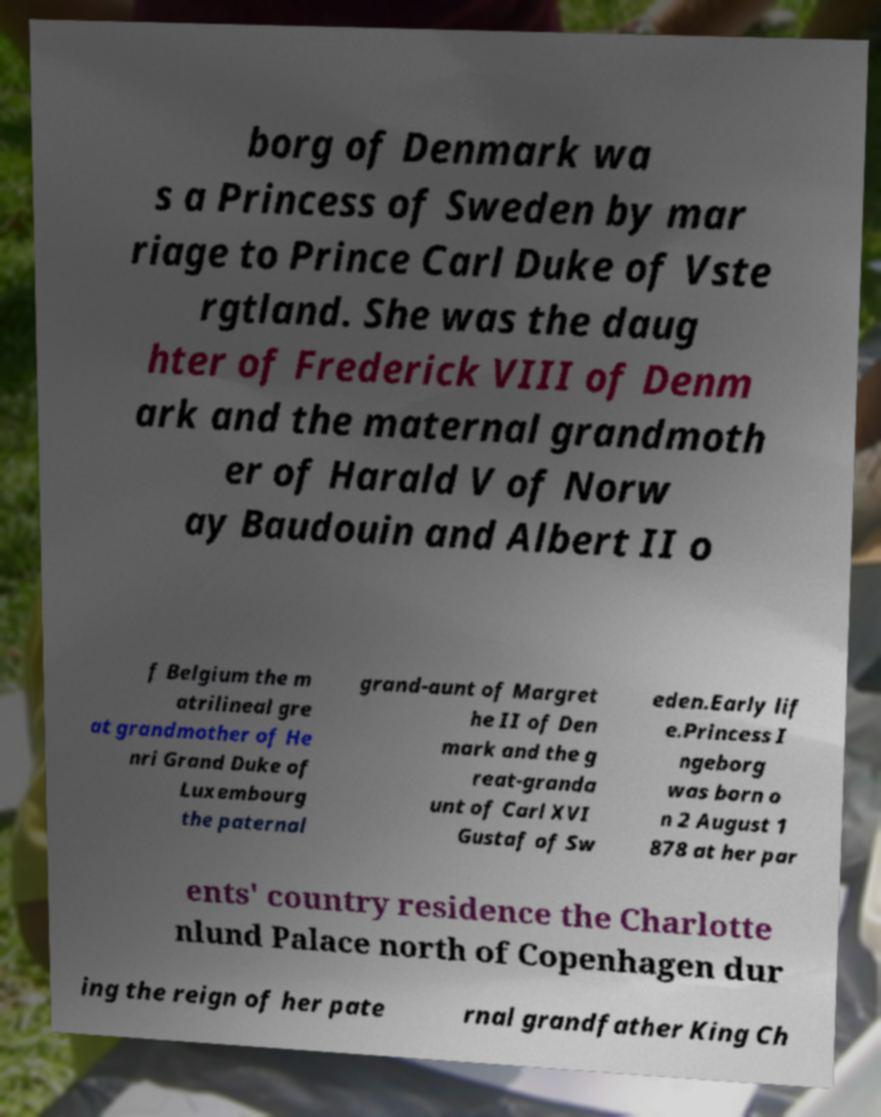There's text embedded in this image that I need extracted. Can you transcribe it verbatim? borg of Denmark wa s a Princess of Sweden by mar riage to Prince Carl Duke of Vste rgtland. She was the daug hter of Frederick VIII of Denm ark and the maternal grandmoth er of Harald V of Norw ay Baudouin and Albert II o f Belgium the m atrilineal gre at grandmother of He nri Grand Duke of Luxembourg the paternal grand-aunt of Margret he II of Den mark and the g reat-granda unt of Carl XVI Gustaf of Sw eden.Early lif e.Princess I ngeborg was born o n 2 August 1 878 at her par ents' country residence the Charlotte nlund Palace north of Copenhagen dur ing the reign of her pate rnal grandfather King Ch 